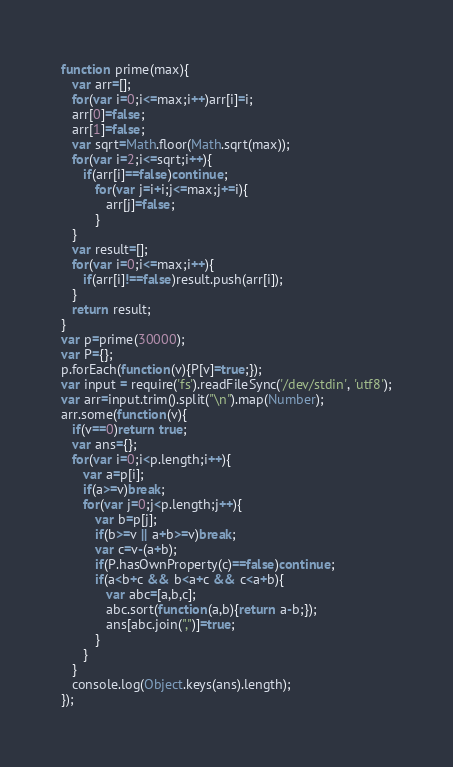Convert code to text. <code><loc_0><loc_0><loc_500><loc_500><_JavaScript_>function prime(max){
   var arr=[];
   for(var i=0;i<=max;i++)arr[i]=i;
   arr[0]=false;
   arr[1]=false;
   var sqrt=Math.floor(Math.sqrt(max));
   for(var i=2;i<=sqrt;i++){
      if(arr[i]==false)continue;
         for(var j=i+i;j<=max;j+=i){
            arr[j]=false;
         }
   }
   var result=[];
   for(var i=0;i<=max;i++){
      if(arr[i]!==false)result.push(arr[i]);
   }
   return result;
}
var p=prime(30000);
var P={};
p.forEach(function(v){P[v]=true;});
var input = require('fs').readFileSync('/dev/stdin', 'utf8');
var arr=input.trim().split("\n").map(Number);
arr.some(function(v){
   if(v==0)return true;
   var ans={};
   for(var i=0;i<p.length;i++){
      var a=p[i];
      if(a>=v)break;
      for(var j=0;j<p.length;j++){
         var b=p[j];
         if(b>=v || a+b>=v)break;
         var c=v-(a+b);
         if(P.hasOwnProperty(c)==false)continue;
         if(a<b+c && b<a+c && c<a+b){
            var abc=[a,b,c];
            abc.sort(function(a,b){return a-b;});
            ans[abc.join(",")]=true;
         }
      }
   }
   console.log(Object.keys(ans).length);
});</code> 